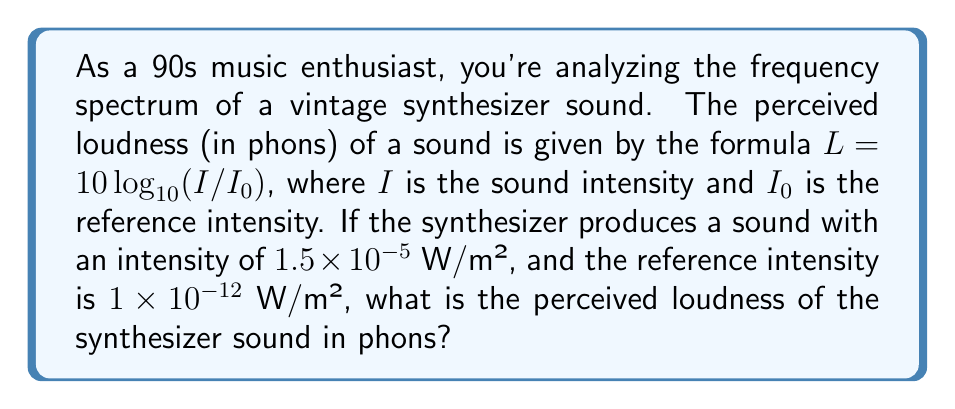What is the answer to this math problem? Let's approach this step-by-step:

1) We're given the formula for perceived loudness:
   $L = 10 \log_{10}(I/I_0)$

2) We know:
   $I = 1.5 \times 10^{-5}$ W/m²
   $I_0 = 1 \times 10^{-12}$ W/m²

3) Let's substitute these values into the formula:
   $L = 10 \log_{10}((1.5 \times 10^{-5})/(1 \times 10^{-12}))$

4) Simplify inside the parentheses:
   $L = 10 \log_{10}(1.5 \times 10^7)$

5) Use the logarithm property $\log_a(x \times 10^n) = \log_a(x) + n$:
   $L = 10 (\log_{10}(1.5) + 7)$

6) Calculate $\log_{10}(1.5)$ (you can use a calculator for this):
   $\log_{10}(1.5) \approx 0.17609125905568124$

7) Substitute this value:
   $L = 10 (0.17609125905568124 + 7)$
   $L = 10 (7.17609125905568124)$

8) Multiply:
   $L = 71.7609125905568124$

9) Round to two decimal places:
   $L \approx 71.76$ phons
Answer: 71.76 phons 